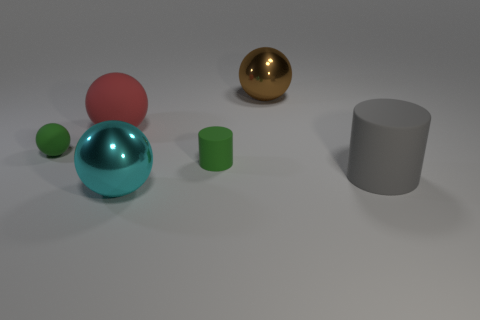Subtract all red balls. How many balls are left? 3 Subtract all big balls. How many balls are left? 1 Add 3 cyan metallic spheres. How many objects exist? 9 Subtract all purple spheres. Subtract all purple cylinders. How many spheres are left? 4 Subtract all balls. How many objects are left? 2 Add 2 big purple metal objects. How many big purple metal objects exist? 2 Subtract 0 blue cubes. How many objects are left? 6 Subtract all tiny matte cylinders. Subtract all large cyan shiny objects. How many objects are left? 4 Add 5 large red objects. How many large red objects are left? 6 